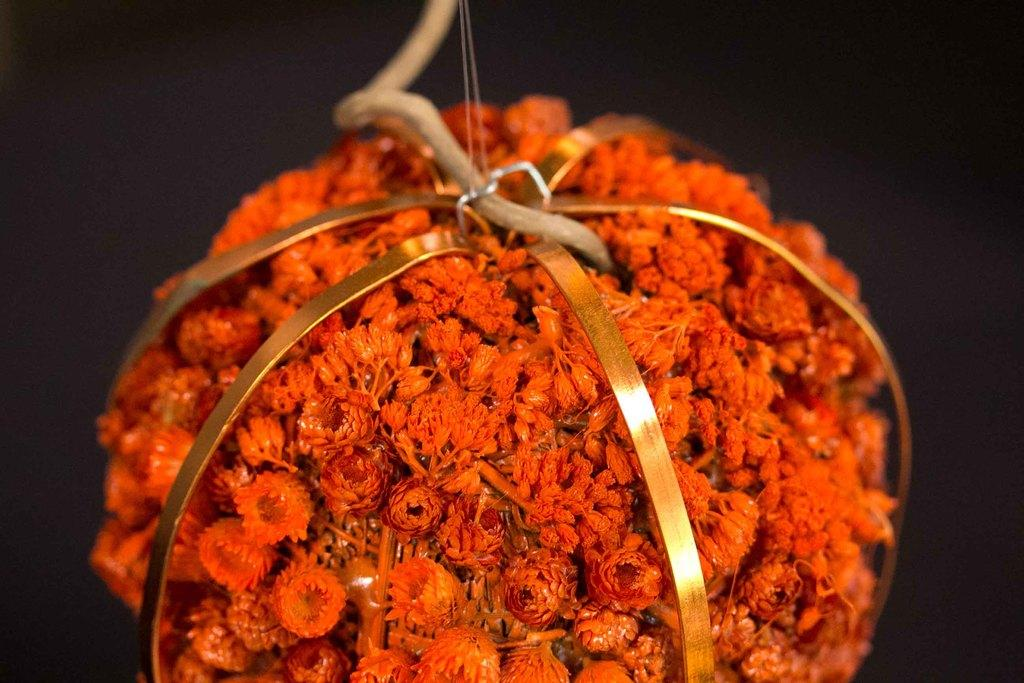What is the main subject of the image? The main subject of the image is a crochet. Can you describe the design of the crochet? The crochet resembles flowers. How many credits are given for completing the crochet project in the image? There is no information about credits in the image, as it features a crochet that resembles flowers. Are there any tubs visible in the image? No, there are no tubs present in the image. 